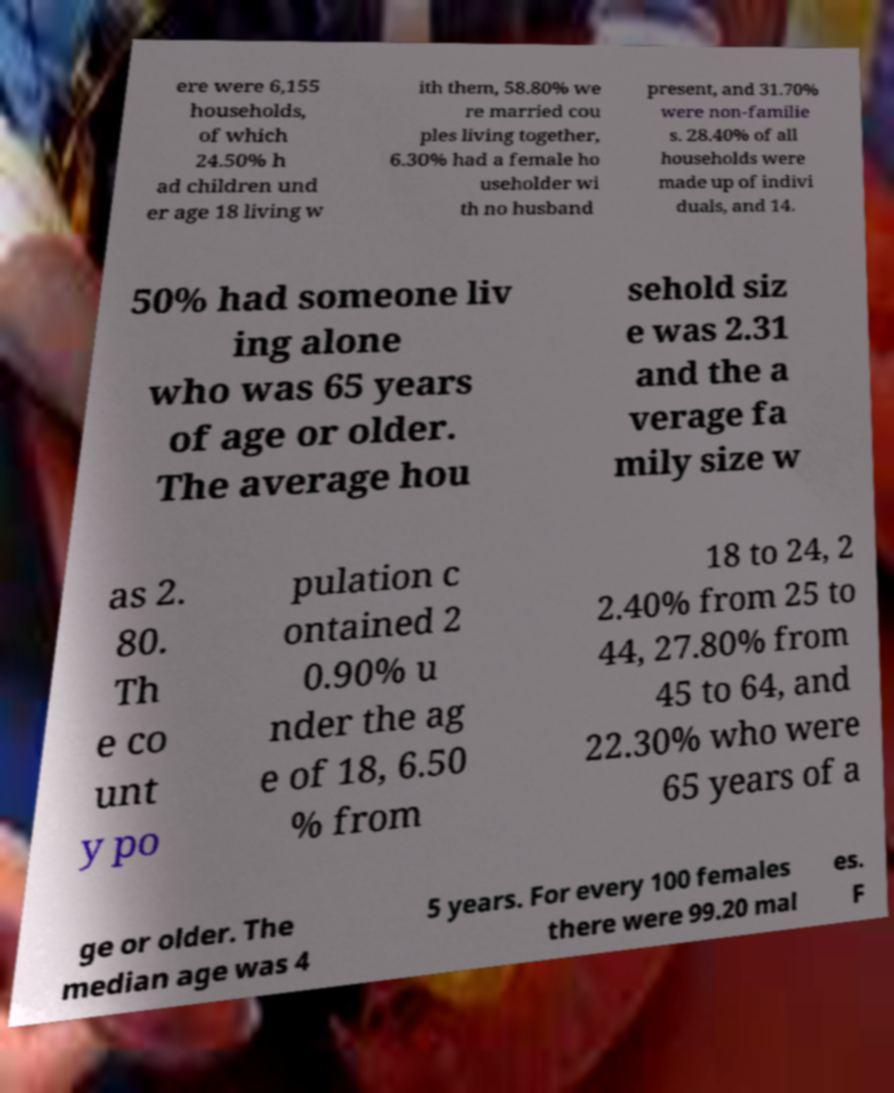What messages or text are displayed in this image? I need them in a readable, typed format. ere were 6,155 households, of which 24.50% h ad children und er age 18 living w ith them, 58.80% we re married cou ples living together, 6.30% had a female ho useholder wi th no husband present, and 31.70% were non-familie s. 28.40% of all households were made up of indivi duals, and 14. 50% had someone liv ing alone who was 65 years of age or older. The average hou sehold siz e was 2.31 and the a verage fa mily size w as 2. 80. Th e co unt y po pulation c ontained 2 0.90% u nder the ag e of 18, 6.50 % from 18 to 24, 2 2.40% from 25 to 44, 27.80% from 45 to 64, and 22.30% who were 65 years of a ge or older. The median age was 4 5 years. For every 100 females there were 99.20 mal es. F 